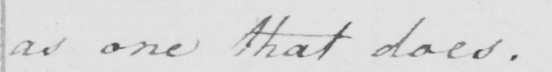Transcribe the text shown in this historical manuscript line. as one that does . 